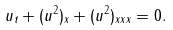Convert formula to latex. <formula><loc_0><loc_0><loc_500><loc_500>u _ { t } + ( u ^ { 2 } ) _ { x } + ( u ^ { 2 } ) _ { x x x } = 0 .</formula> 